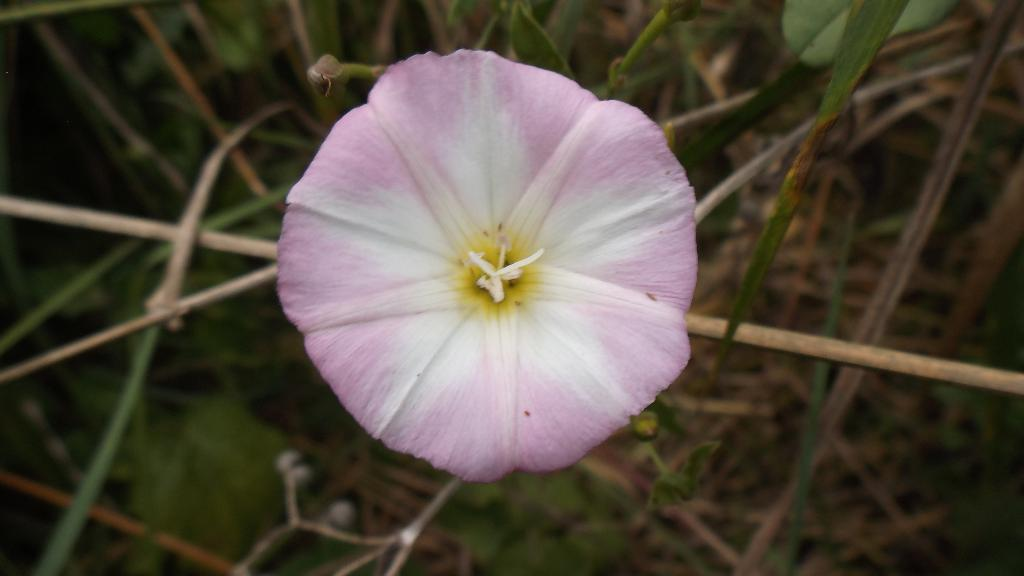What is the main subject of the image? There is a flower in the image. What parts of the flower are visible in the image? There are stems and leaves visible in the image. What type of needle can be seen in the image? There is no needle present in the image. What kind of music is being played in the background of the image? There is no music or background audio present in the image. 